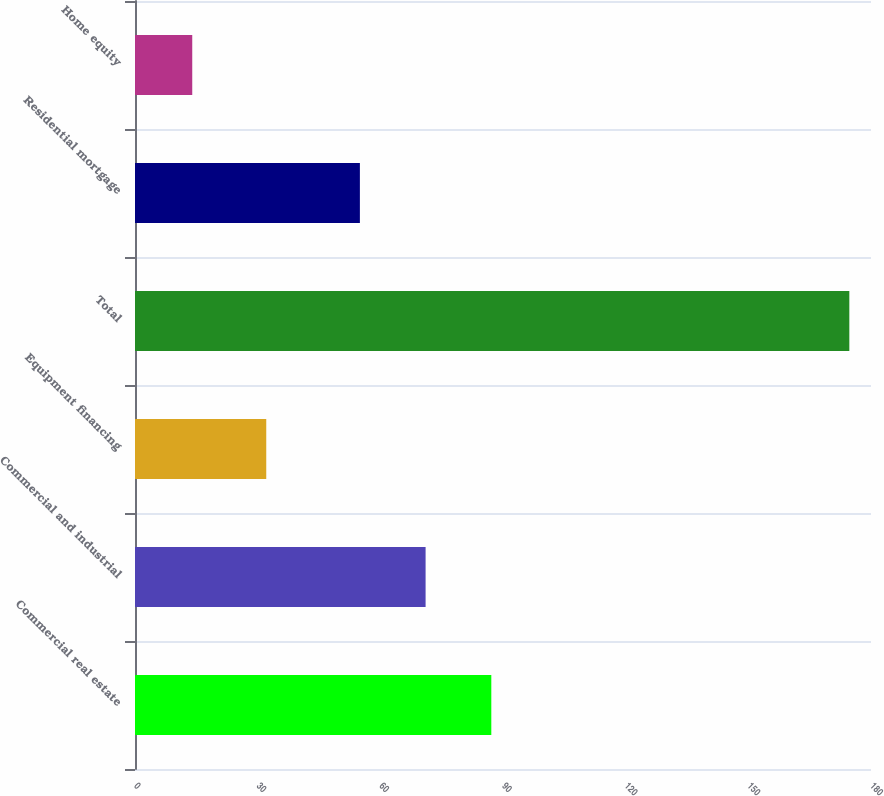<chart> <loc_0><loc_0><loc_500><loc_500><bar_chart><fcel>Commercial real estate<fcel>Commercial and industrial<fcel>Equipment financing<fcel>Total<fcel>Residential mortgage<fcel>Home equity<nl><fcel>87.14<fcel>71.07<fcel>32.1<fcel>174.7<fcel>55<fcel>14<nl></chart> 